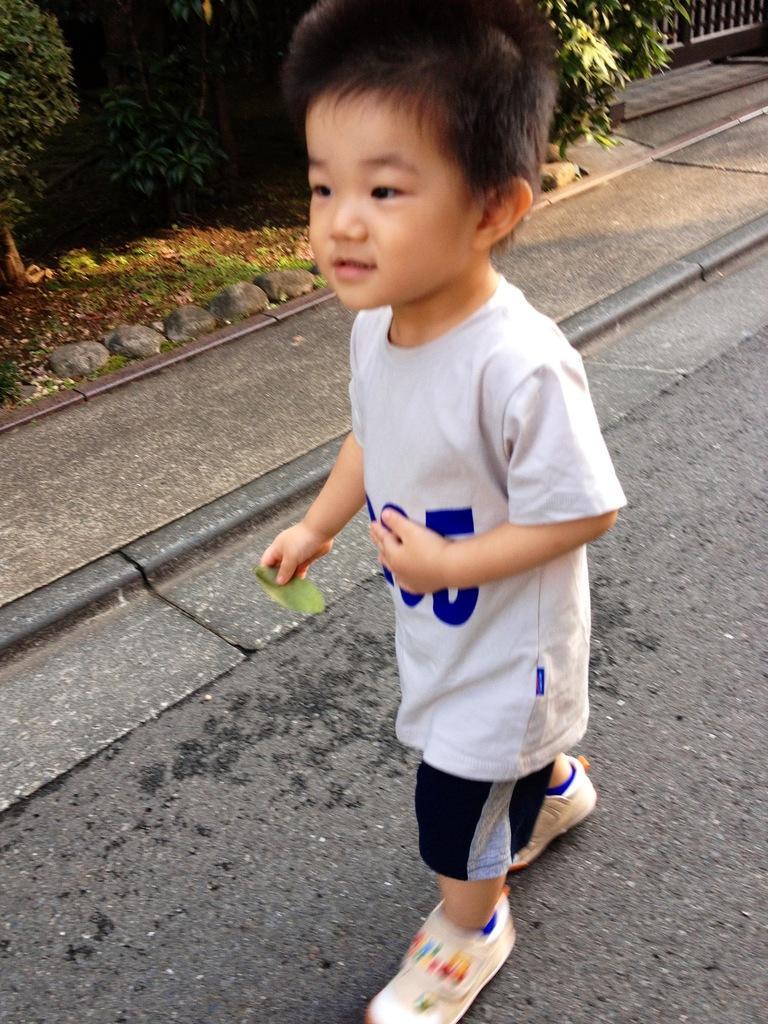How would you summarize this image in a sentence or two? In this image, I can see a boy standing on the road. In the background, there are plants and rocks. 